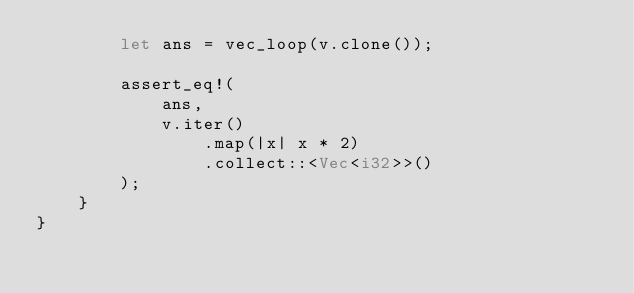Convert code to text. <code><loc_0><loc_0><loc_500><loc_500><_Rust_>        let ans = vec_loop(v.clone());

        assert_eq!(
            ans,
            v.iter()
                .map(|x| x * 2)
                .collect::<Vec<i32>>()
        );
    }
}
</code> 